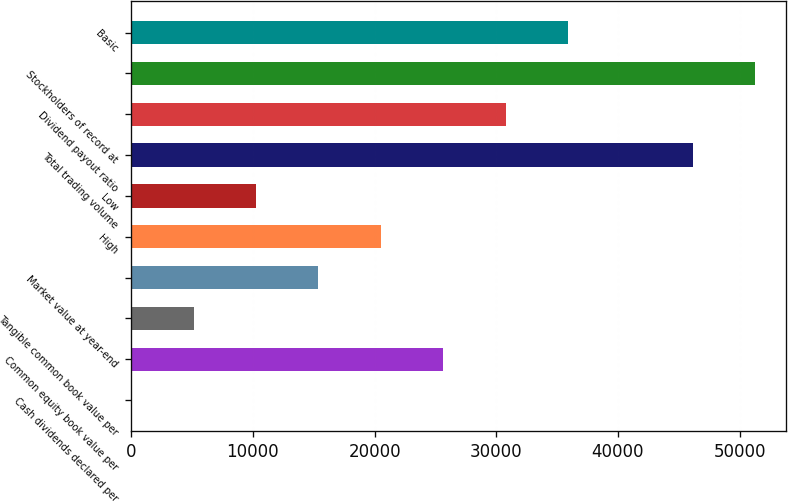<chart> <loc_0><loc_0><loc_500><loc_500><bar_chart><fcel>Cash dividends declared per<fcel>Common equity book value per<fcel>Tangible common book value per<fcel>Market value at year-end<fcel>High<fcel>Low<fcel>Total trading volume<fcel>Dividend payout ratio<fcel>Stockholders of record at<fcel>Basic<nl><fcel>0.23<fcel>25635.1<fcel>5127.21<fcel>15381.2<fcel>20508.2<fcel>10254.2<fcel>46143.1<fcel>30762.1<fcel>51270<fcel>35889.1<nl></chart> 